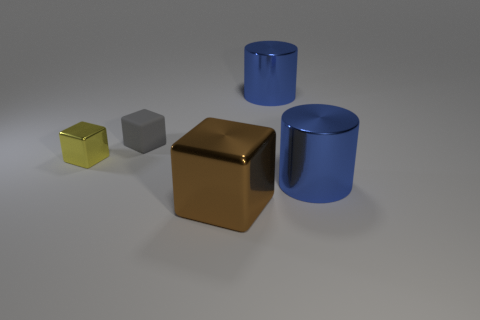Is there anything else that is the same material as the tiny gray object? After observing the image, it appears that there are no other objects of the same material as the small gray cube. The materials of the other objects differ, which can be inferred by their distinct colors and surfaces. 